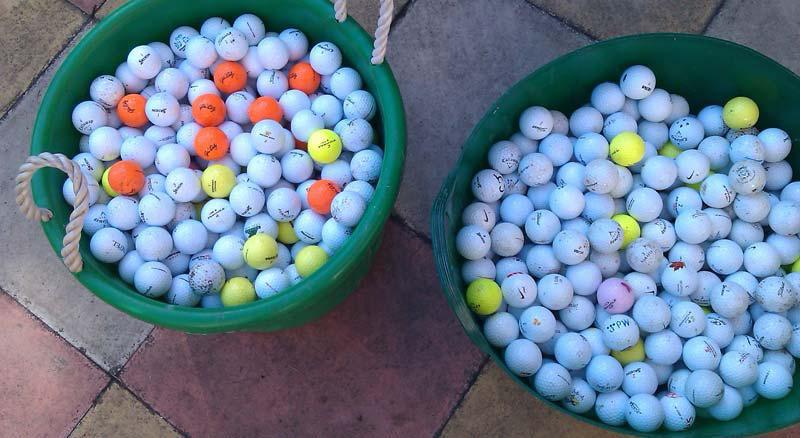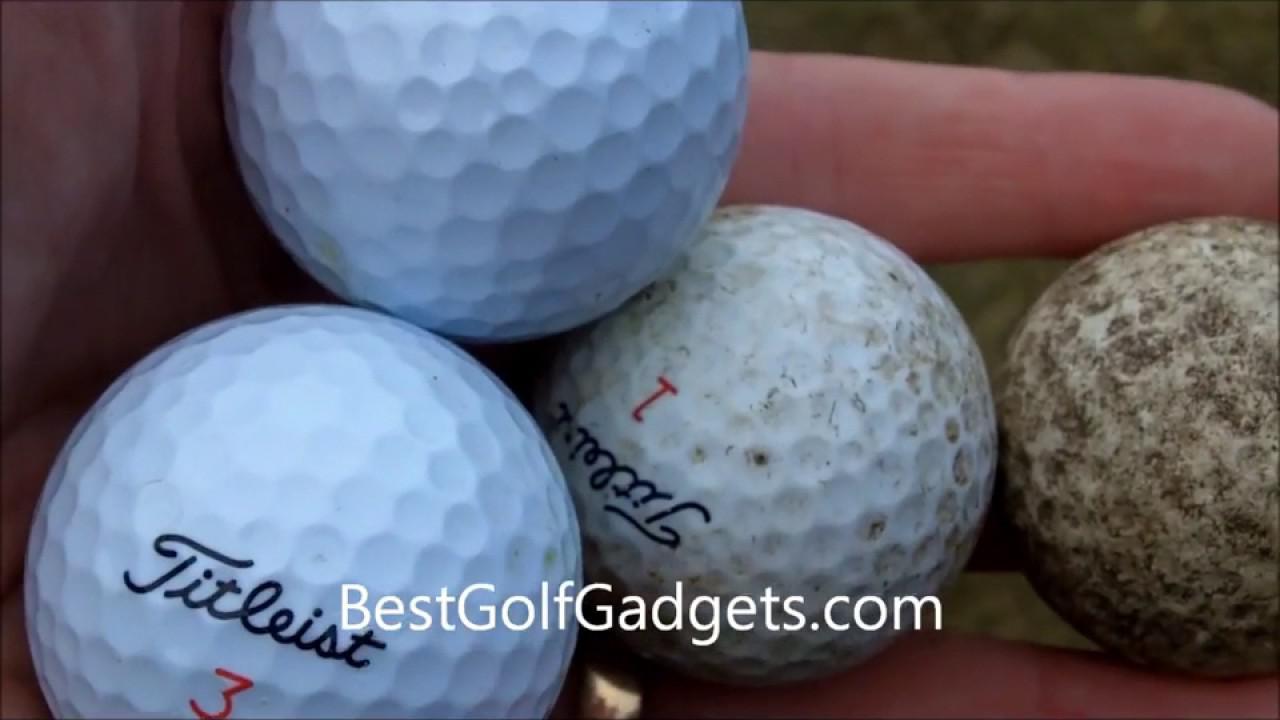The first image is the image on the left, the second image is the image on the right. For the images shown, is this caption "One image shows a golf ball bucket with at least two bright orange balls." true? Answer yes or no. Yes. The first image is the image on the left, the second image is the image on the right. Evaluate the accuracy of this statement regarding the images: "There are two cardboard boxes in the image on the right.". Is it true? Answer yes or no. No. 